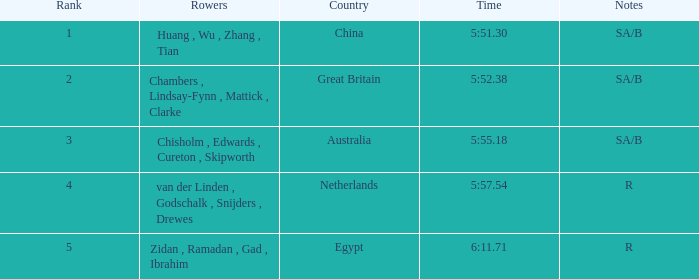What country is ranked larger than 4? Egypt. 